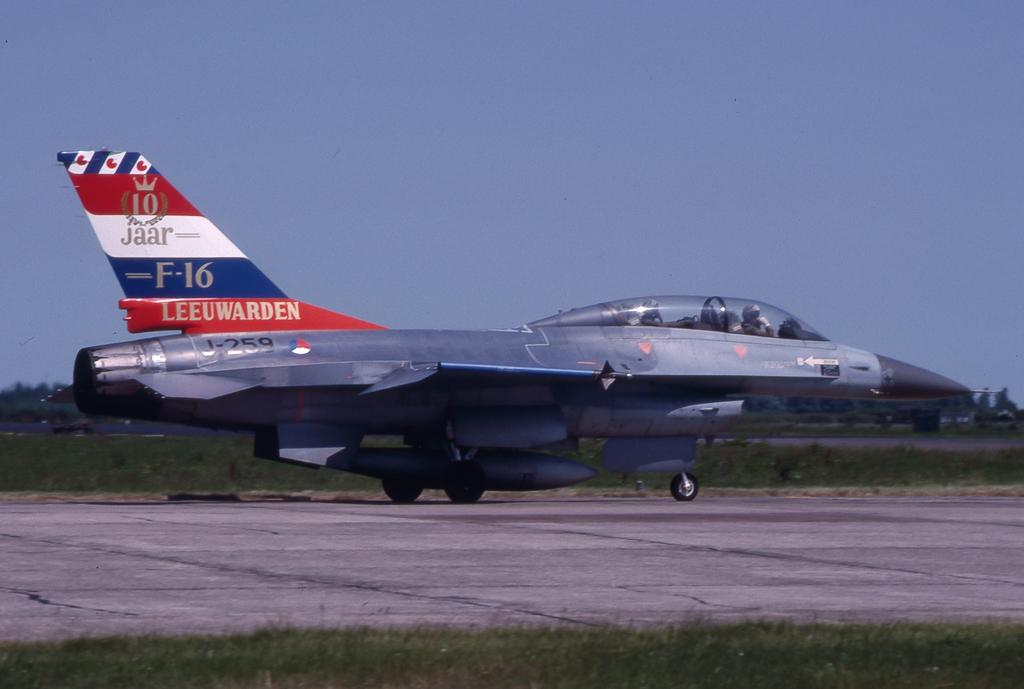<image>
Relay a brief, clear account of the picture shown. The identification number for the F-16 Leeuwarden airplane is J-259. 